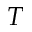<formula> <loc_0><loc_0><loc_500><loc_500>T</formula> 